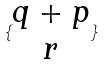Convert formula to latex. <formula><loc_0><loc_0><loc_500><loc_500>\{ \begin{matrix} q + p \\ r \end{matrix} \}</formula> 